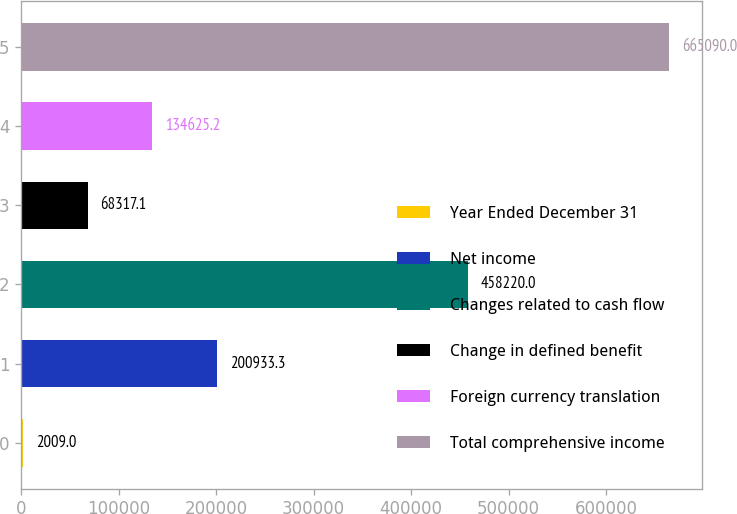Convert chart. <chart><loc_0><loc_0><loc_500><loc_500><bar_chart><fcel>Year Ended December 31<fcel>Net income<fcel>Changes related to cash flow<fcel>Change in defined benefit<fcel>Foreign currency translation<fcel>Total comprehensive income<nl><fcel>2009<fcel>200933<fcel>458220<fcel>68317.1<fcel>134625<fcel>665090<nl></chart> 